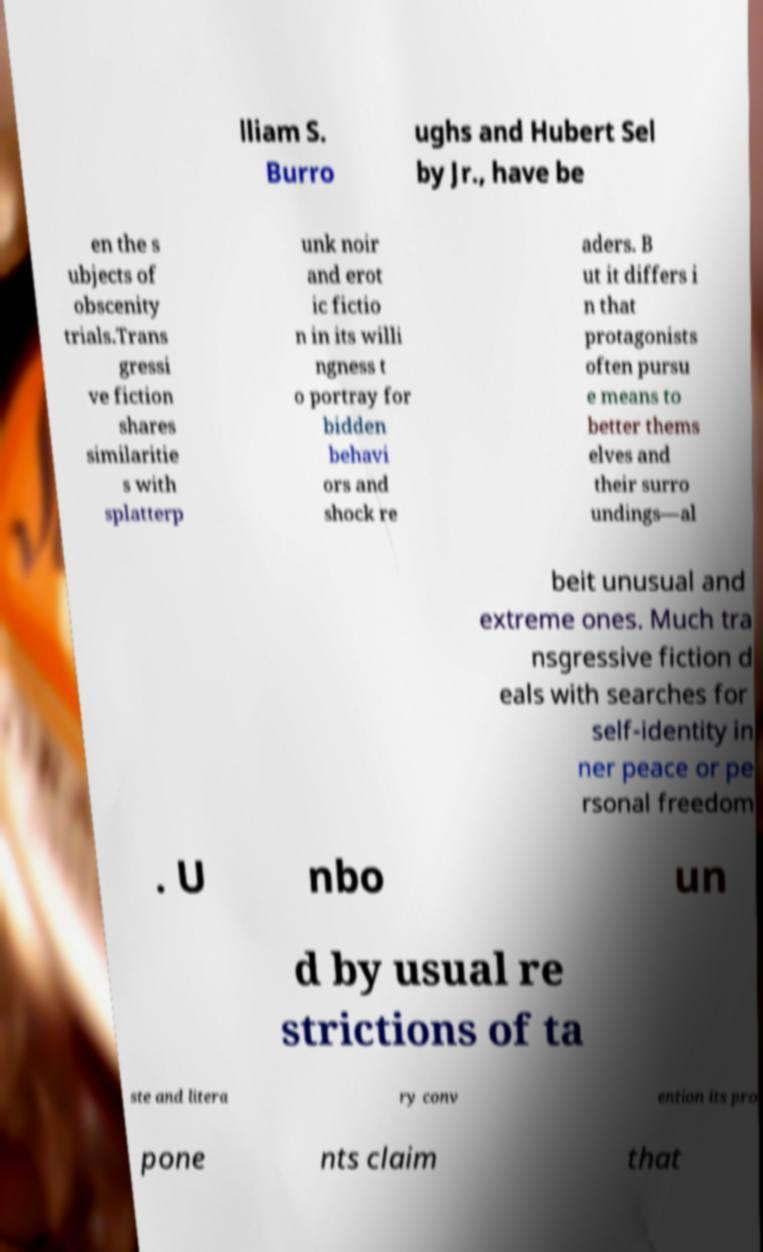Please read and relay the text visible in this image. What does it say? lliam S. Burro ughs and Hubert Sel by Jr., have be en the s ubjects of obscenity trials.Trans gressi ve fiction shares similaritie s with splatterp unk noir and erot ic fictio n in its willi ngness t o portray for bidden behavi ors and shock re aders. B ut it differs i n that protagonists often pursu e means to better thems elves and their surro undings—al beit unusual and extreme ones. Much tra nsgressive fiction d eals with searches for self-identity in ner peace or pe rsonal freedom . U nbo un d by usual re strictions of ta ste and litera ry conv ention its pro pone nts claim that 